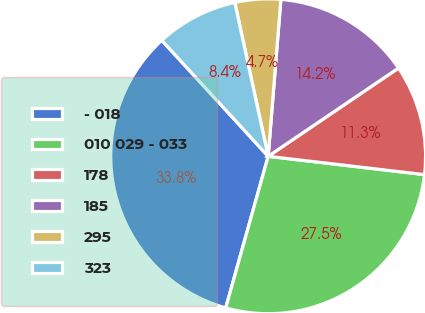Convert chart. <chart><loc_0><loc_0><loc_500><loc_500><pie_chart><fcel>- 018<fcel>010 029 - 033<fcel>178<fcel>185<fcel>295<fcel>323<nl><fcel>33.84%<fcel>27.49%<fcel>11.33%<fcel>14.24%<fcel>4.69%<fcel>8.41%<nl></chart> 